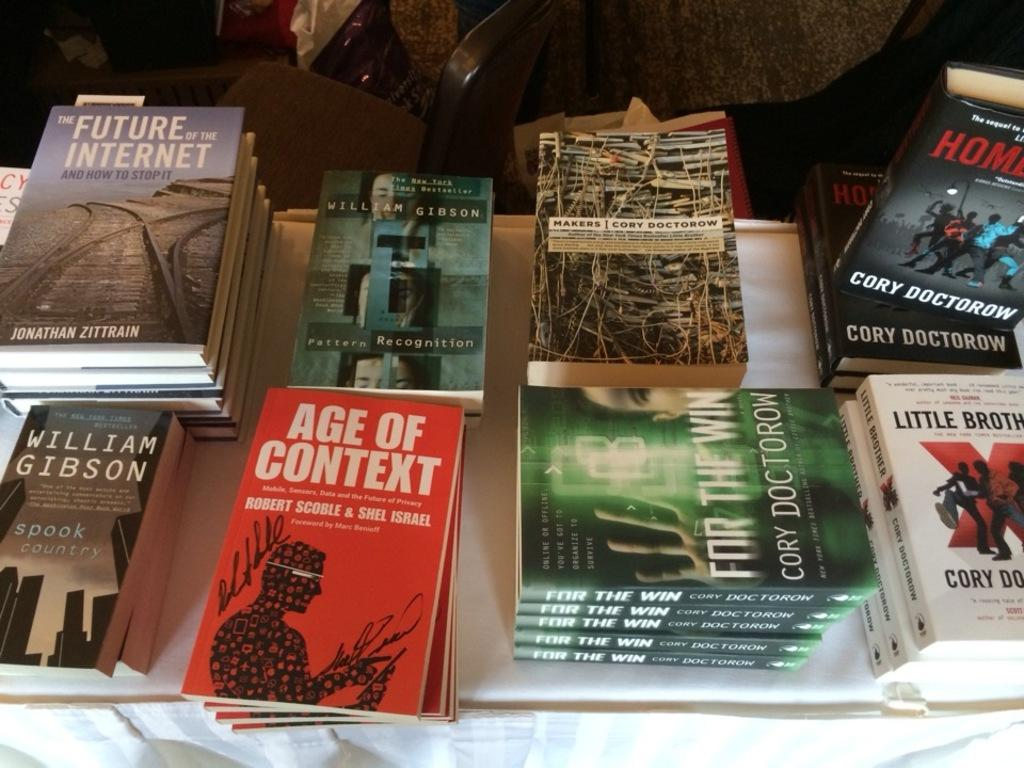<image>
Describe the image concisely. A stack of Age Of Context books next to a William Gibson book. 